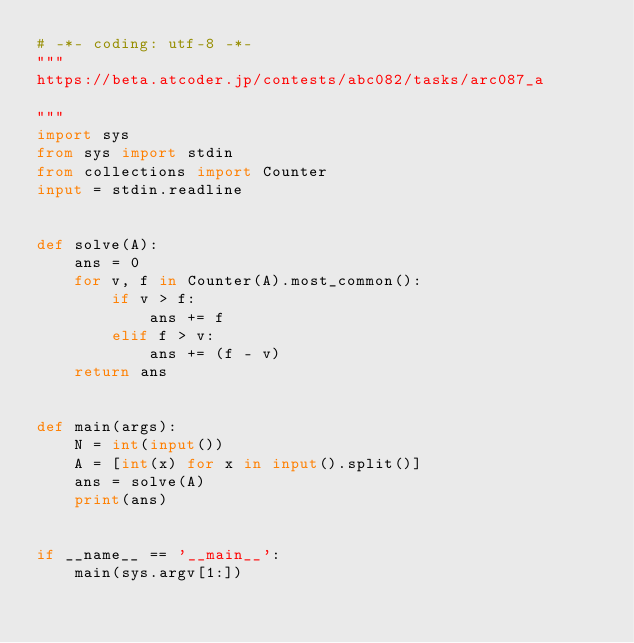Convert code to text. <code><loc_0><loc_0><loc_500><loc_500><_Python_># -*- coding: utf-8 -*-
"""
https://beta.atcoder.jp/contests/abc082/tasks/arc087_a

"""
import sys
from sys import stdin
from collections import Counter
input = stdin.readline


def solve(A):
    ans = 0
    for v, f in Counter(A).most_common():
        if v > f:
            ans += f
        elif f > v:
            ans += (f - v)
    return ans


def main(args):
    N = int(input())
    A = [int(x) for x in input().split()]
    ans = solve(A)
    print(ans)


if __name__ == '__main__':
    main(sys.argv[1:])
    
</code> 